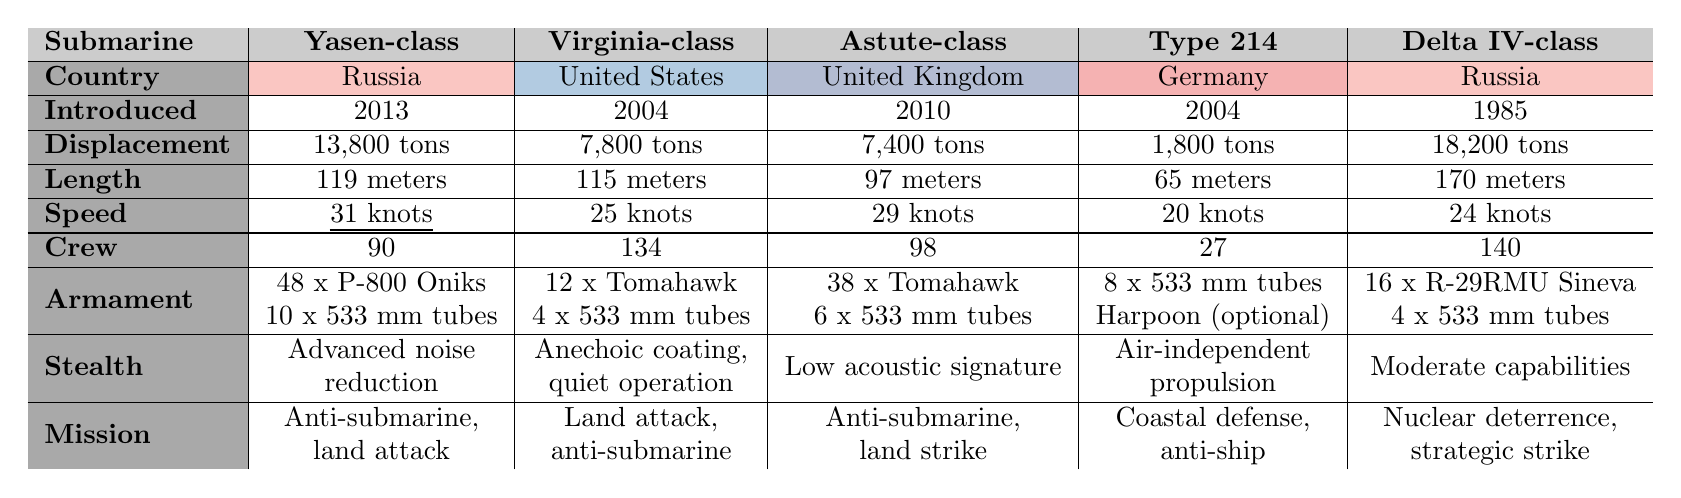What is the speed of the Yasen-class submarine? The table lists the Yasen-class submarine's speed under the 'Speed' row, which states it is 31 knots.
Answer: 31 knots Which submarine has the highest displacement? The 'Displacement' row compares the weights of the submarines. The Delta IV-class has a displacement of 18,200 tons, which is higher than the others.
Answer: Delta IV-class How many torpedo tubes does the Type 214 submarine have? The number of torpedo tubes for the Type 214 submarine can be found in the 'Armament' row, where it states "8 x 533 mm tubes."
Answer: 8 Is the Astute-class submarine faster than the Virginia-class? The 'Speed' row shows that the Astute-class has a speed of 29 knots while the Virginia-class has a speed of 25 knots, confirming that Astute-class is faster.
Answer: Yes What is the average length of the submarines listed? The lengths are 119, 115, 97, 65, and 170 meters. Adding these gives 586 meters. Dividing by the number of submarines (5) gives an average of 117.2 meters.
Answer: 117.2 meters Which submarine has the most crew members? By checking the 'Crew' row, the Virginia-class has 134 crew members, which is more than any other submarine listed.
Answer: Virginia-class Which submarines are designed for anti-submarine warfare missions? The table indicates that the Yasen-class, Virginia-class, Astute-class, and Delta IV-class are listed for anti-submarine missions. Therefore, these four submarines fit the criteria.
Answer: Yasen-class, Virginia-class, Astute-class, Delta IV-class What is the difference in speed between the Yasen-class and Type 214? The Yasen-class speed is 31 knots and the Type 214's speed is 20 knots. The difference is 31 - 20 = 11 knots.
Answer: 11 knots What type of propulsion system does the Type 214 use? Under the 'Stealth' row for the Type 214, it mentions "Air-independent propulsion for extended stealth."
Answer: Air-independent propulsion Which submarine has the smallest crew size, and what is that size? The 'Crew' row shows that the Type 214 has the smallest crew with 27 members.
Answer: Type 214, 27 members 